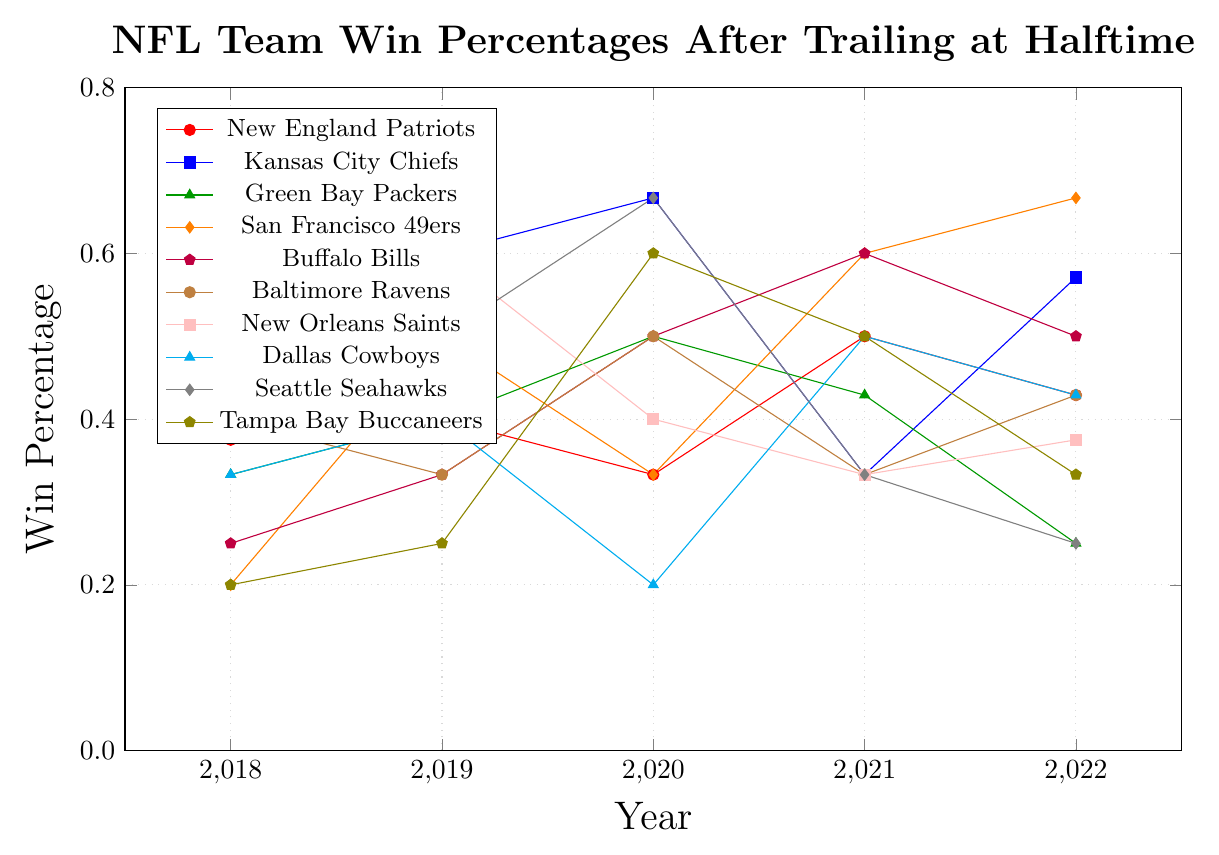What team had the highest win percentage after trailing at halftime in 2019? Locate the line representing each team above 2019 on the x-axis. Identify the team with the highest y-value at that point, which corresponds to their win percentage.
Answer: Kansas City Chiefs How did the Buffalo Bills' win percentage change from 2018 to 2022? Compare the Bills' win percentage in 2018 to that in 2022. From 0.250 in 2018 to 0.500 in 2022, the percentage increased.
Answer: Increased Which team showed the most improvement in win percentage from 2018 to 2022? Look at the win percentages for 2018 and 2022 for each team. Calculate the difference for each team and identify the largest positive change.
Answer: San Francisco 49ers Which team had a higher win percentage in 2020, the Green Bay Packers or the Tampa Bay Buccaneers? Compare the y-values of Green Bay Packers and Tampa Bay Buccaneers above the 2020 x-axis. Green Bay Packers had a win percentage of 0.500, while Tampa Bay Buccaneers had 0.600.
Answer: Tampa Bay Buccaneers How did the New England Patriots' win percentage in 2020 compare to their win percentage in 2021? Locate the line representing the New England Patriots and compare the y-values for the years 2020 and 2021. The percentage was 0.333 in 2020 and 0.500 in 2021.
Answer: Increased Rank the following teams from highest to lowest win percentage in 2022: Kansas City Chiefs, San Francisco 49ers, and Baltimore Ravens. Compare the y-values in 2022 for the three teams. Kansas City Chiefs (0.571), San Francisco 49ers (0.667), and Baltimore Ravens (0.429).
Answer: San Francisco 49ers, Kansas City Chiefs, Baltimore Ravens Which team had the most consistent win percentage from 2018 to 2022? Examine the lines representing each team. The team with the smallest variation in y-values year-to-year is the most consistent.
Answer: Baltimore Ravens Across the five years, which team had the highest single annual win percentage, and in which year? Scan all lines to find the highest y-value and identify the corresponding team and year. The Kansas City Chiefs had a win percentage of 0.667 in 2020 and Seattle Seahawks had a win percentage of 0.667 in 2020.
Answer: Kansas City Chiefs and Seattle Seahawks, 2020 Which team's win percentage had the most significant drop from one year to the next, and between which years did this occur? Look at all the lines to identify the biggest negative change between two consecutive years. Seattle Seahawks dropped from 0.667 in 2020 to 0.333 in 2021.
Answer: Seattle Seahawks, 2020 to 2021 